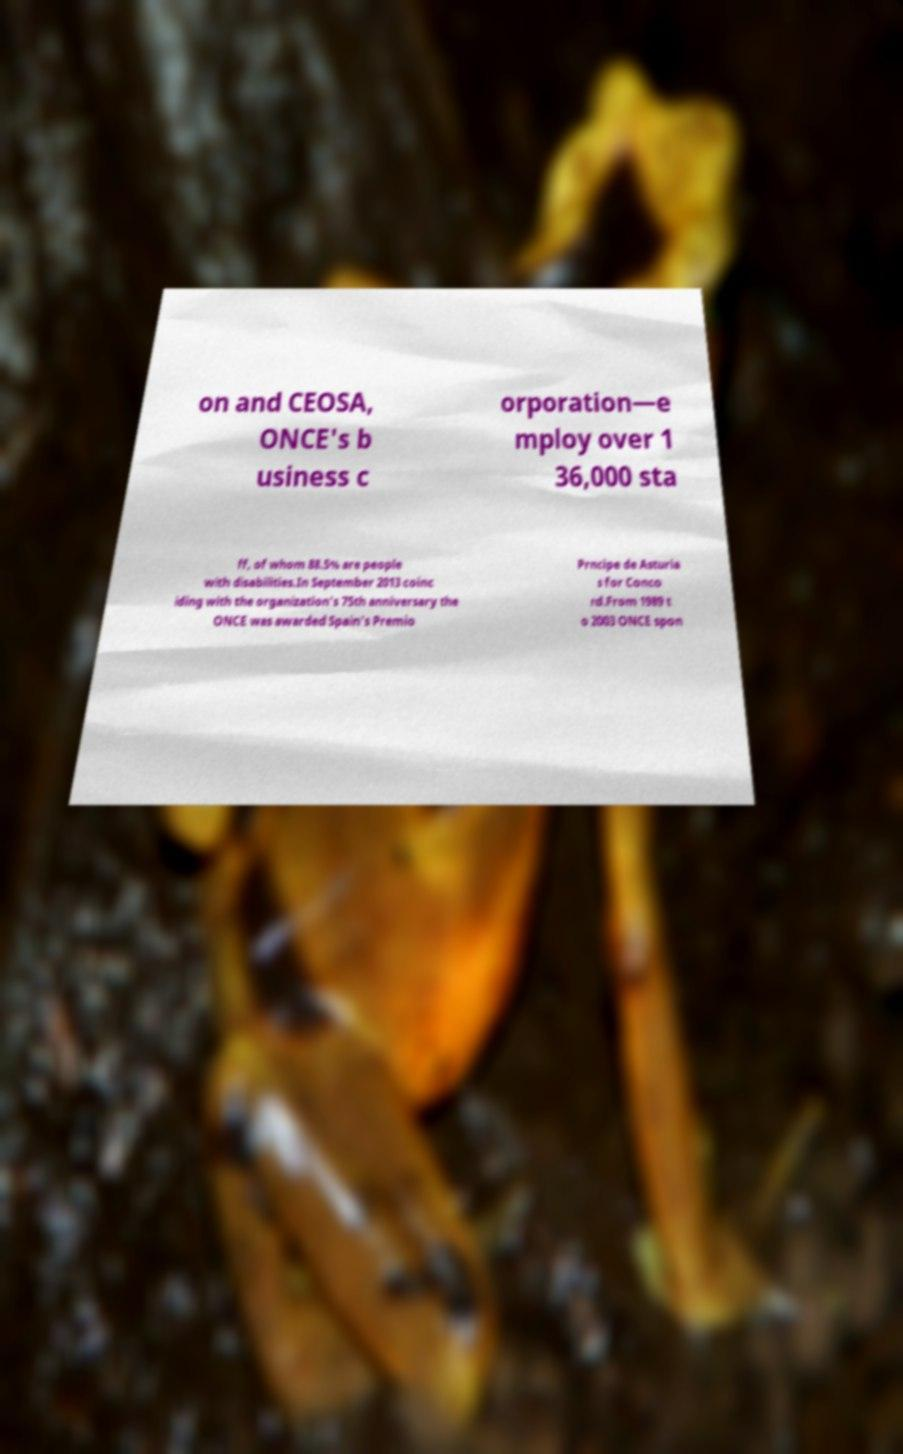I need the written content from this picture converted into text. Can you do that? on and CEOSA, ONCE's b usiness c orporation—e mploy over 1 36,000 sta ff, of whom 88.5% are people with disabilities.In September 2013 coinc iding with the organization's 75th anniversary the ONCE was awarded Spain's Premio Prncipe de Asturia s for Conco rd.From 1989 t o 2003 ONCE spon 